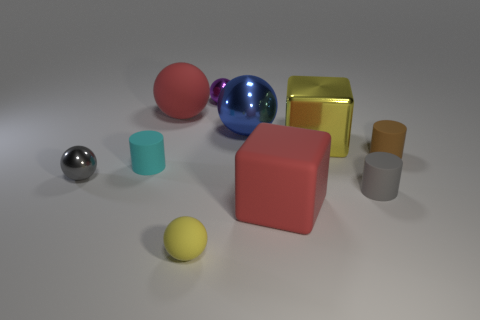Subtract all small gray cylinders. How many cylinders are left? 2 Subtract all cylinders. How many objects are left? 7 Subtract all yellow cubes. How many green balls are left? 0 Subtract all big green metallic cubes. Subtract all tiny gray matte cylinders. How many objects are left? 9 Add 4 yellow metallic cubes. How many yellow metallic cubes are left? 5 Add 9 shiny blocks. How many shiny blocks exist? 10 Subtract all gray spheres. How many spheres are left? 4 Subtract 0 gray blocks. How many objects are left? 10 Subtract 1 cubes. How many cubes are left? 1 Subtract all gray spheres. Subtract all gray blocks. How many spheres are left? 4 